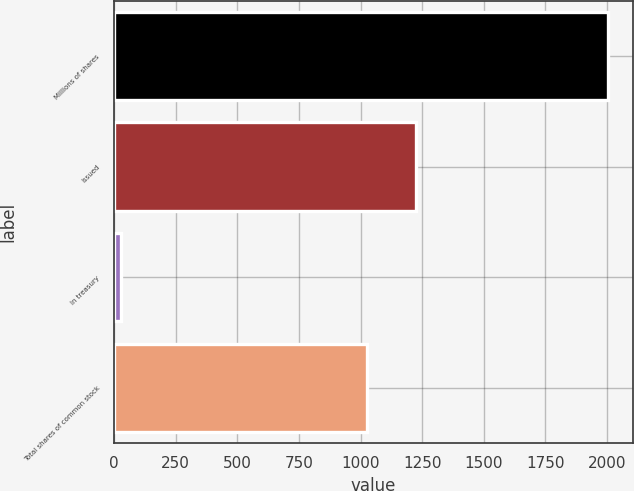<chart> <loc_0><loc_0><loc_500><loc_500><bar_chart><fcel>Millions of shares<fcel>Issued<fcel>In treasury<fcel>Total shares of common stock<nl><fcel>2005<fcel>1225.9<fcel>26<fcel>1028<nl></chart> 